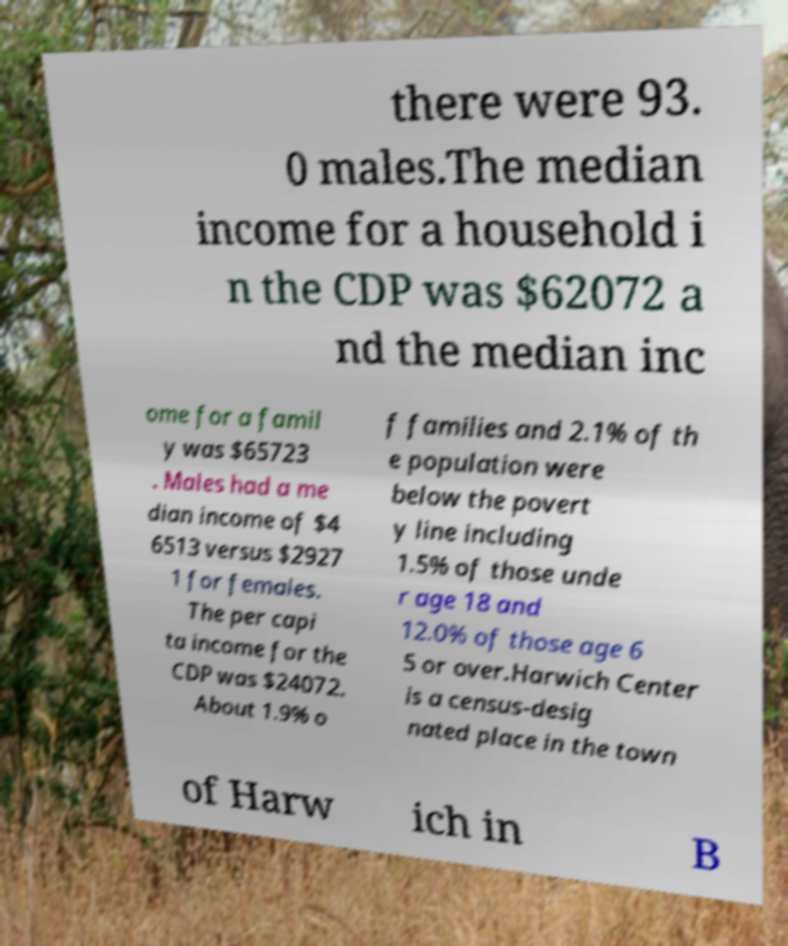Could you extract and type out the text from this image? there were 93. 0 males.The median income for a household i n the CDP was $62072 a nd the median inc ome for a famil y was $65723 . Males had a me dian income of $4 6513 versus $2927 1 for females. The per capi ta income for the CDP was $24072. About 1.9% o f families and 2.1% of th e population were below the povert y line including 1.5% of those unde r age 18 and 12.0% of those age 6 5 or over.Harwich Center is a census-desig nated place in the town of Harw ich in B 